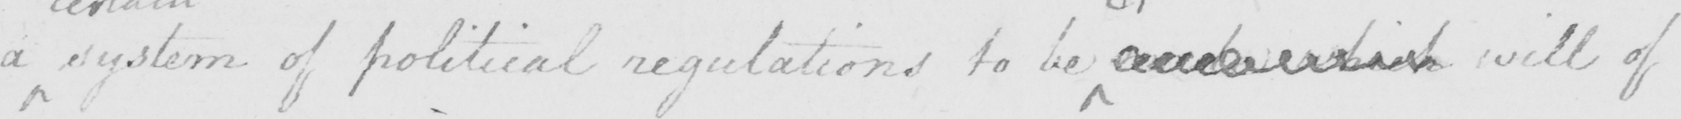What text is written in this handwritten line? a system of political regulations to be  made which will of 